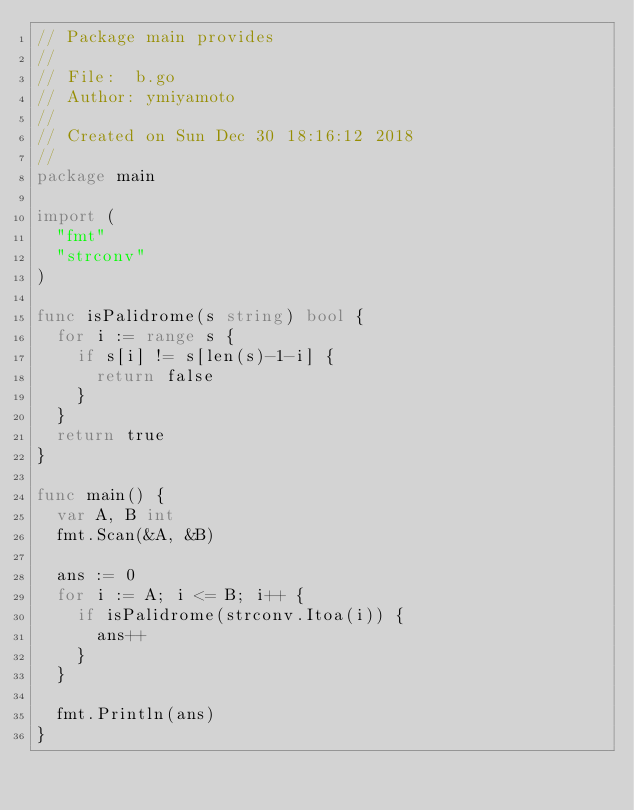<code> <loc_0><loc_0><loc_500><loc_500><_Go_>// Package main provides
//
// File:  b.go
// Author: ymiyamoto
//
// Created on Sun Dec 30 18:16:12 2018
//
package main

import (
	"fmt"
	"strconv"
)

func isPalidrome(s string) bool {
	for i := range s {
		if s[i] != s[len(s)-1-i] {
			return false
		}
	}
	return true
}

func main() {
	var A, B int
	fmt.Scan(&A, &B)

	ans := 0
	for i := A; i <= B; i++ {
		if isPalidrome(strconv.Itoa(i)) {
			ans++
		}
	}

	fmt.Println(ans)
}
</code> 